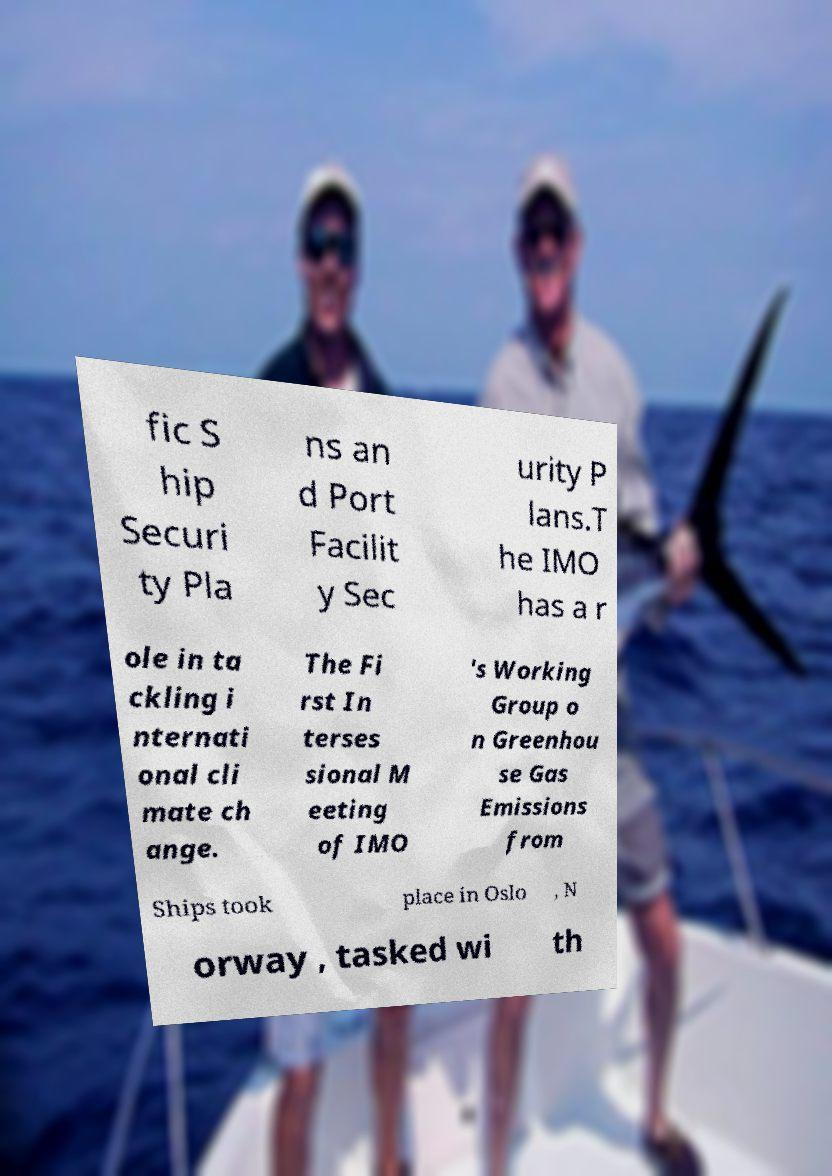Please read and relay the text visible in this image. What does it say? fic S hip Securi ty Pla ns an d Port Facilit y Sec urity P lans.T he IMO has a r ole in ta ckling i nternati onal cli mate ch ange. The Fi rst In terses sional M eeting of IMO 's Working Group o n Greenhou se Gas Emissions from Ships took place in Oslo , N orway , tasked wi th 